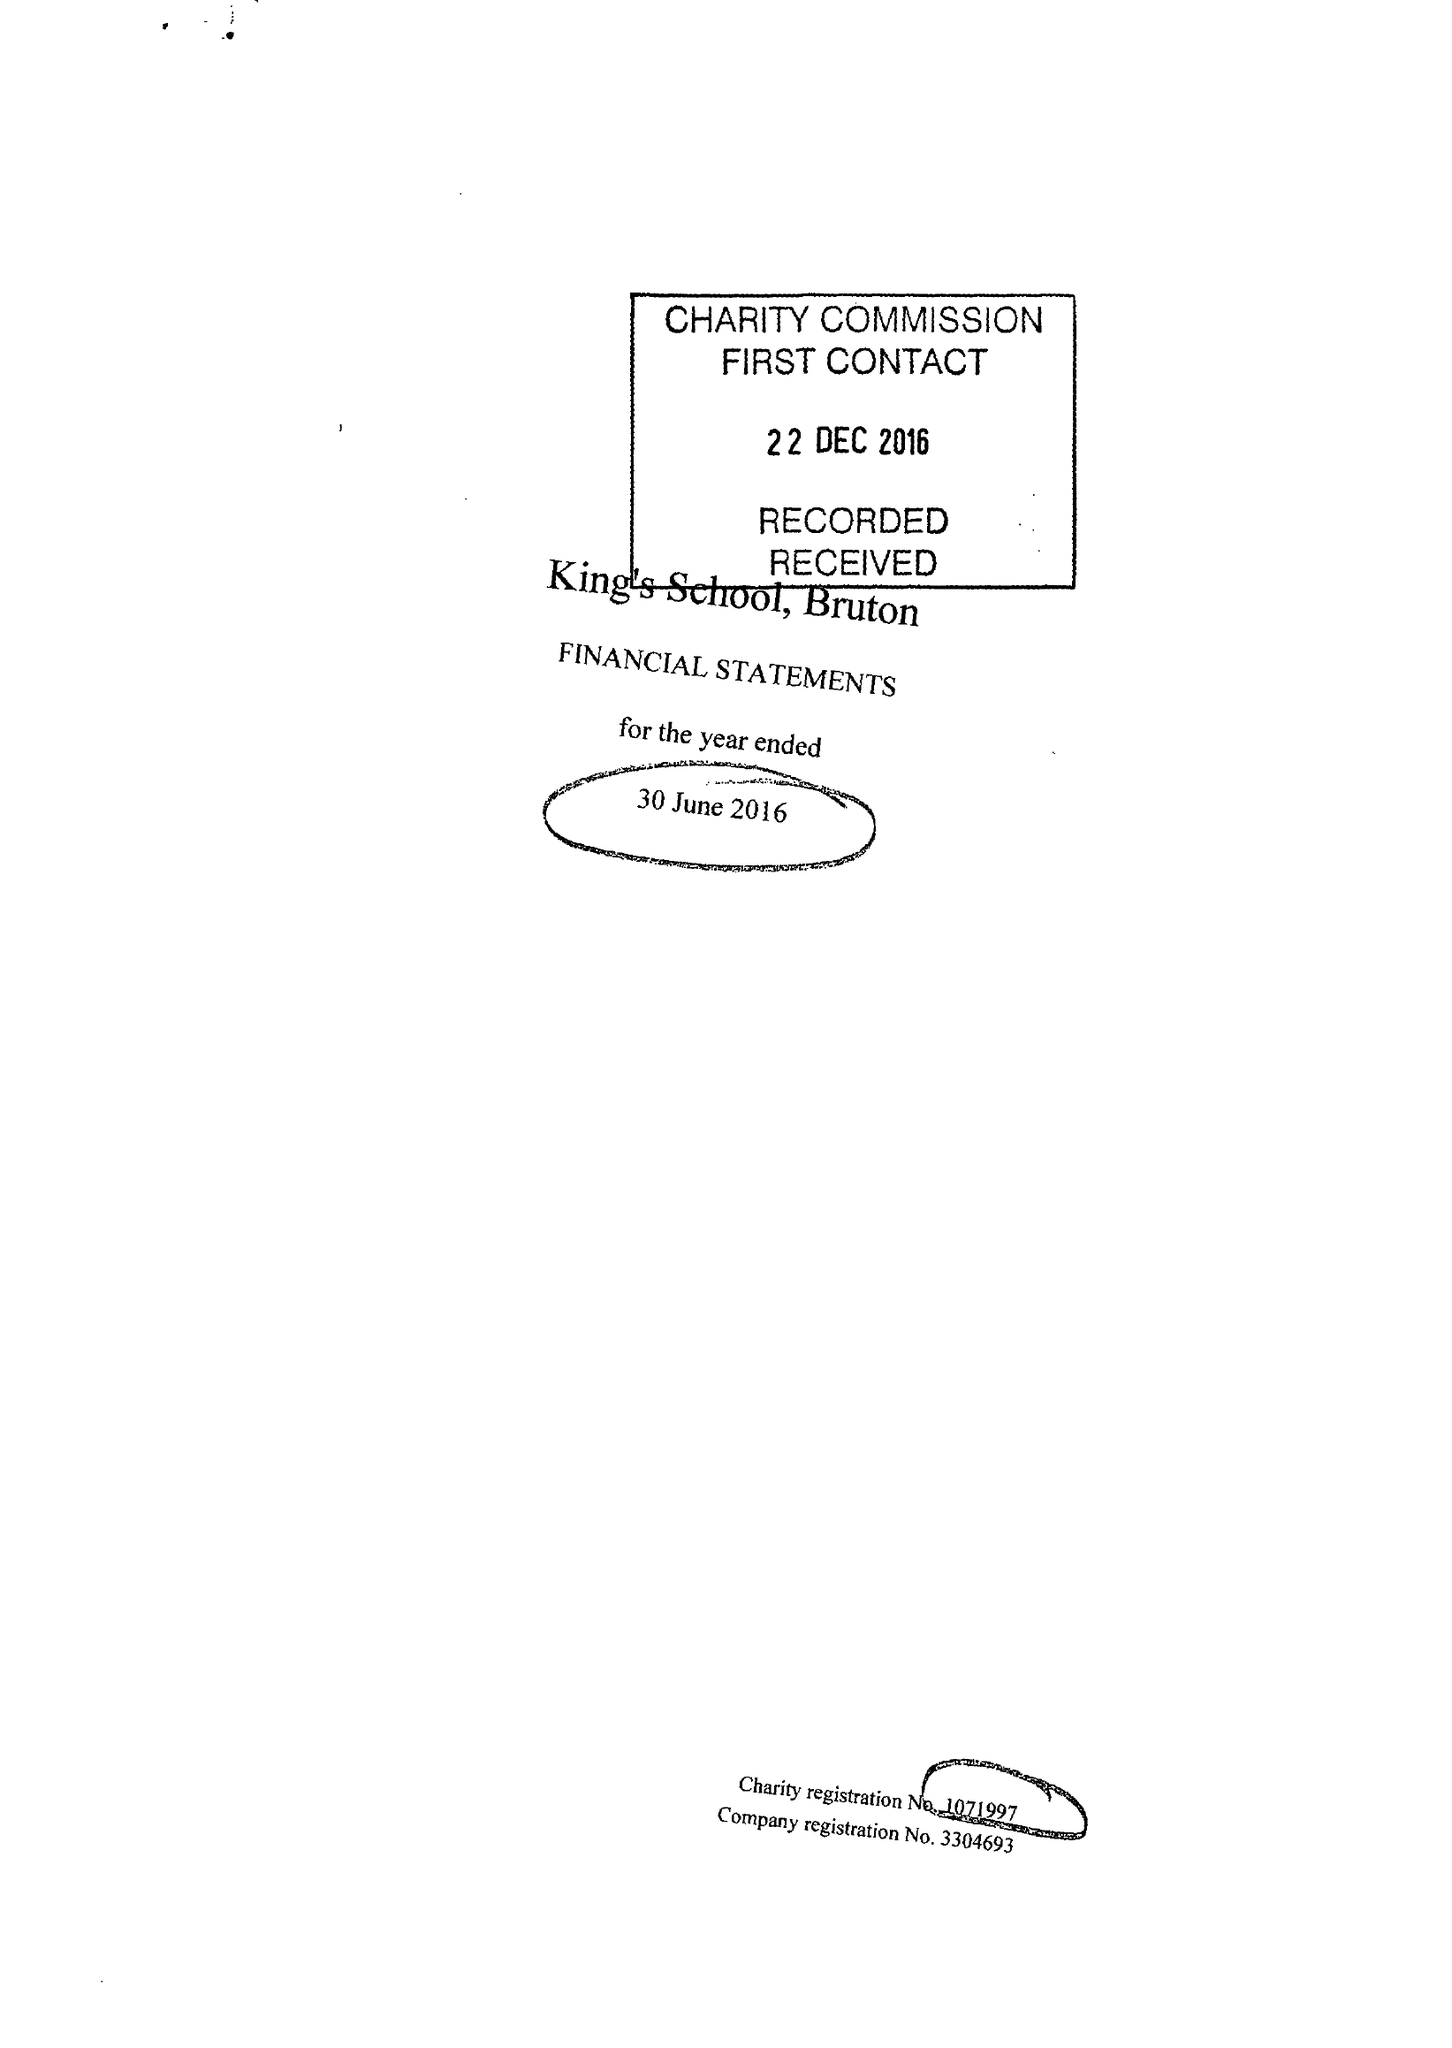What is the value for the address__post_town?
Answer the question using a single word or phrase. BRUTON 